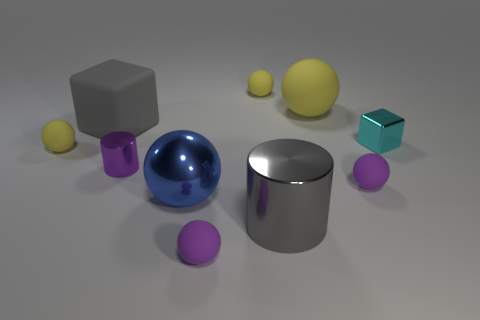Subtract all green cylinders. How many purple balls are left? 2 Subtract all blue balls. How many balls are left? 5 Subtract all big shiny spheres. How many spheres are left? 5 Subtract 4 spheres. How many spheres are left? 2 Subtract all green spheres. Subtract all red cylinders. How many spheres are left? 6 Subtract all balls. How many objects are left? 4 Add 9 tiny red shiny spheres. How many tiny red shiny spheres exist? 9 Subtract 0 yellow cubes. How many objects are left? 10 Subtract all tiny cyan objects. Subtract all small yellow matte things. How many objects are left? 7 Add 8 metal spheres. How many metal spheres are left? 9 